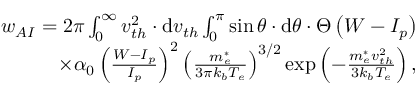<formula> <loc_0><loc_0><loc_500><loc_500>\begin{array} { r } { w _ { A I } = 2 \pi \int _ { 0 } ^ { \infty } v _ { t h } ^ { 2 } \cdot d v _ { t h } \int _ { 0 } ^ { \pi } \sin \theta \cdot d \theta \cdot \Theta \left ( W - I _ { p } \right ) } \\ { \times \alpha _ { 0 } \left ( \frac { W - I _ { p } } { I _ { p } } \right ) ^ { 2 } \left ( \frac { m _ { e } ^ { * } } { 3 \pi k _ { b } T _ { e } } \right ) ^ { 3 / 2 } \exp \left ( - \frac { m _ { e } ^ { * } v _ { t h } ^ { 2 } } { 3 k _ { b } T _ { e } } \right ) , } \end{array}</formula> 